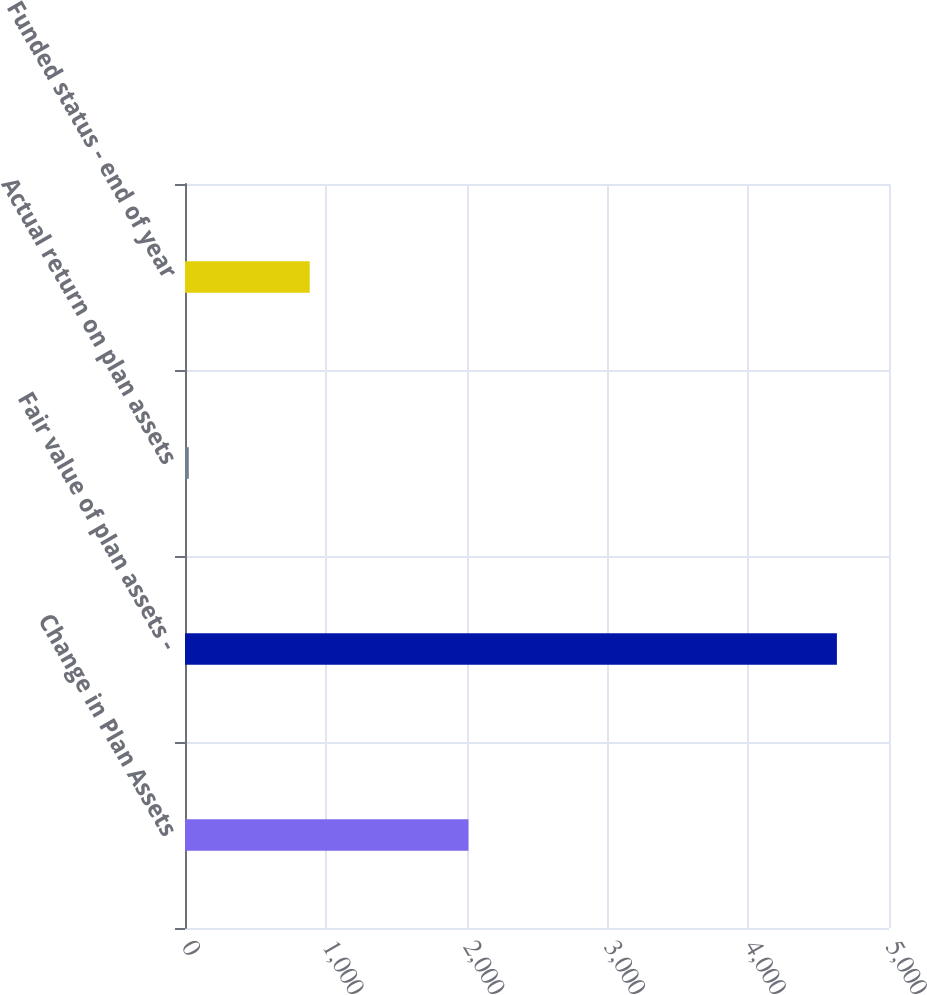<chart> <loc_0><loc_0><loc_500><loc_500><bar_chart><fcel>Change in Plan Assets<fcel>Fair value of plan assets -<fcel>Actual return on plan assets<fcel>Funded status - end of year<nl><fcel>2013<fcel>4630<fcel>27<fcel>886<nl></chart> 